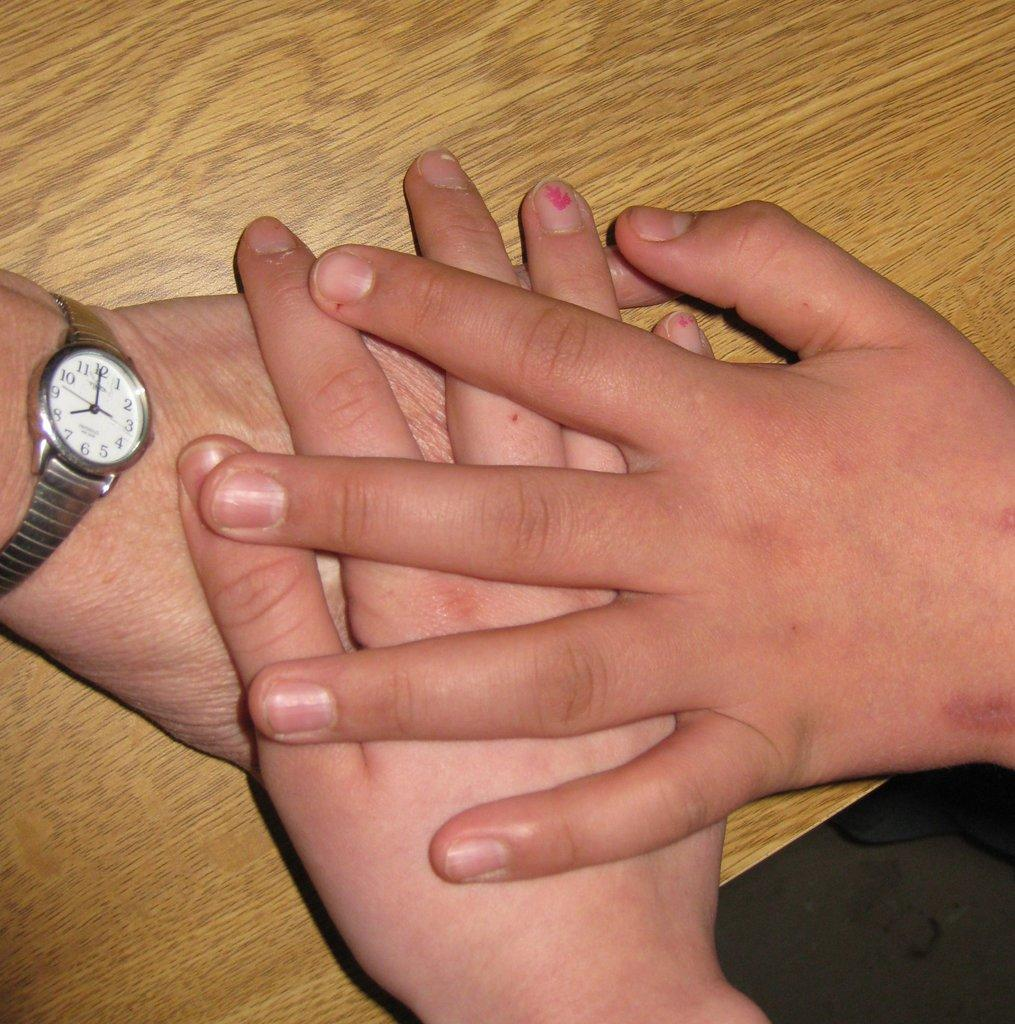<image>
Give a short and clear explanation of the subsequent image. Three hands placed on top of each other including the one with a wrist watch showing 8 o'clock. 